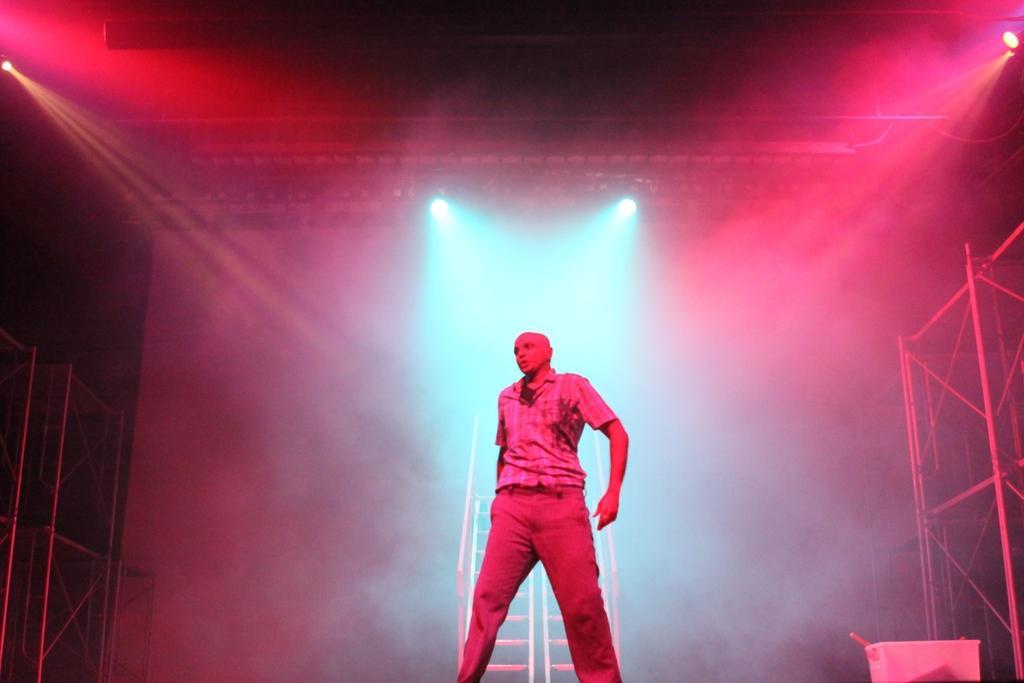Please provide a concise description of this image. In this image there is a man in the middle. At the top there are different colour lights. On the right side there is a stand. In the background there is a staircase. On the left side there is a stand which is made up of iron rods. 